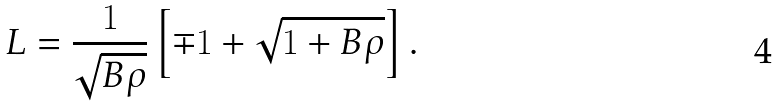<formula> <loc_0><loc_0><loc_500><loc_500>L = \frac { 1 } { \sqrt { B \rho } } \left [ \mp 1 + \sqrt { 1 + B \rho } \right ] .</formula> 